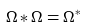Convert formula to latex. <formula><loc_0><loc_0><loc_500><loc_500>\Omega \ast \Omega = \Omega ^ { \ast }</formula> 